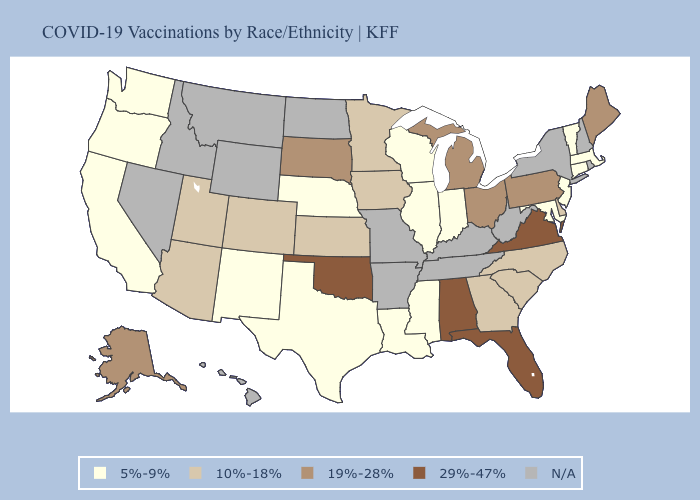What is the lowest value in states that border Alabama?
Concise answer only. 5%-9%. Does Oregon have the lowest value in the USA?
Answer briefly. Yes. What is the highest value in states that border California?
Quick response, please. 10%-18%. Name the states that have a value in the range 5%-9%?
Give a very brief answer. California, Connecticut, Illinois, Indiana, Louisiana, Maryland, Massachusetts, Mississippi, Nebraska, New Jersey, New Mexico, Oregon, Texas, Vermont, Washington, Wisconsin. What is the lowest value in the USA?
Write a very short answer. 5%-9%. What is the lowest value in states that border North Carolina?
Quick response, please. 10%-18%. What is the value of Michigan?
Write a very short answer. 19%-28%. Does the map have missing data?
Give a very brief answer. Yes. Among the states that border Michigan , which have the highest value?
Short answer required. Ohio. What is the value of New York?
Keep it brief. N/A. Does New Jersey have the lowest value in the USA?
Quick response, please. Yes. Does the map have missing data?
Give a very brief answer. Yes. Name the states that have a value in the range 19%-28%?
Be succinct. Alaska, Maine, Michigan, Ohio, Pennsylvania, South Dakota. 